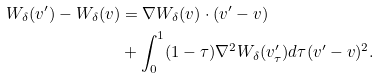<formula> <loc_0><loc_0><loc_500><loc_500>W _ { \delta } ( v ^ { \prime } ) - W _ { \delta } ( v ) & = \nabla W _ { \delta } ( v ) \cdot ( v ^ { \prime } - v ) \\ & + \int _ { 0 } ^ { 1 } ( 1 - \tau ) \nabla ^ { 2 } W _ { \delta } ( v ^ { \prime } _ { \tau } ) d \tau ( v ^ { \prime } - v ) ^ { 2 } .</formula> 